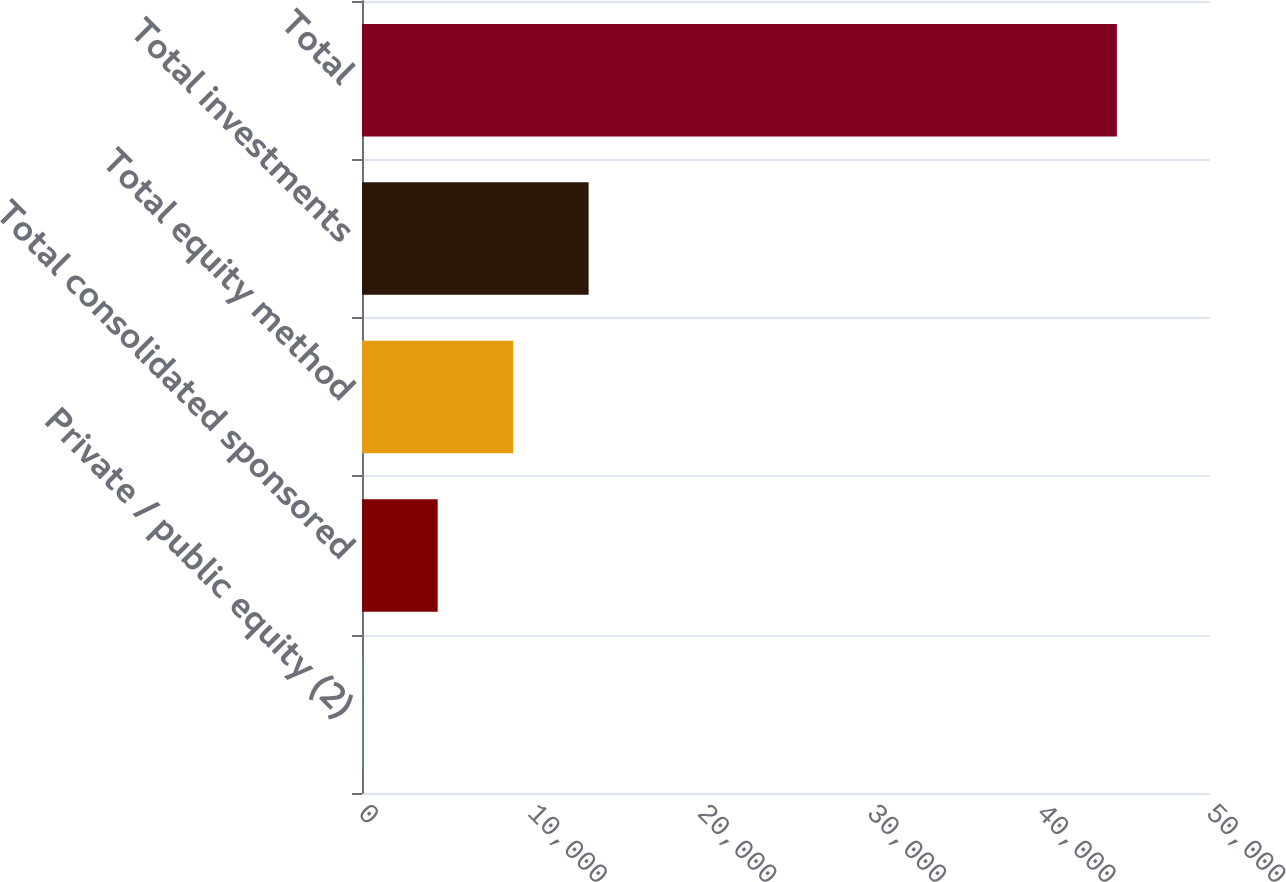<chart> <loc_0><loc_0><loc_500><loc_500><bar_chart><fcel>Private / public equity (2)<fcel>Total consolidated sponsored<fcel>Total equity method<fcel>Total investments<fcel>Total<nl><fcel>13<fcel>4462.8<fcel>8912.6<fcel>13362.4<fcel>44511<nl></chart> 